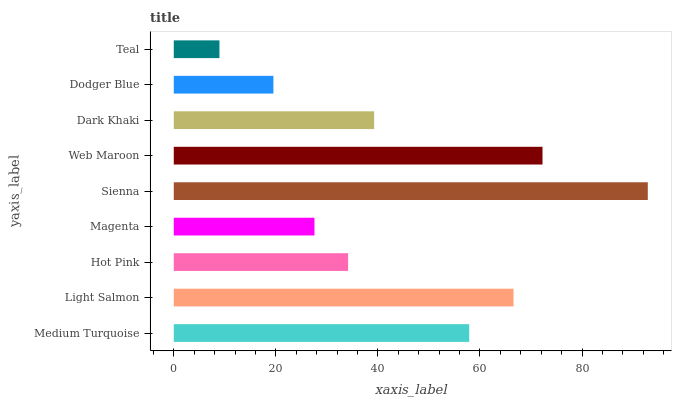Is Teal the minimum?
Answer yes or no. Yes. Is Sienna the maximum?
Answer yes or no. Yes. Is Light Salmon the minimum?
Answer yes or no. No. Is Light Salmon the maximum?
Answer yes or no. No. Is Light Salmon greater than Medium Turquoise?
Answer yes or no. Yes. Is Medium Turquoise less than Light Salmon?
Answer yes or no. Yes. Is Medium Turquoise greater than Light Salmon?
Answer yes or no. No. Is Light Salmon less than Medium Turquoise?
Answer yes or no. No. Is Dark Khaki the high median?
Answer yes or no. Yes. Is Dark Khaki the low median?
Answer yes or no. Yes. Is Teal the high median?
Answer yes or no. No. Is Teal the low median?
Answer yes or no. No. 